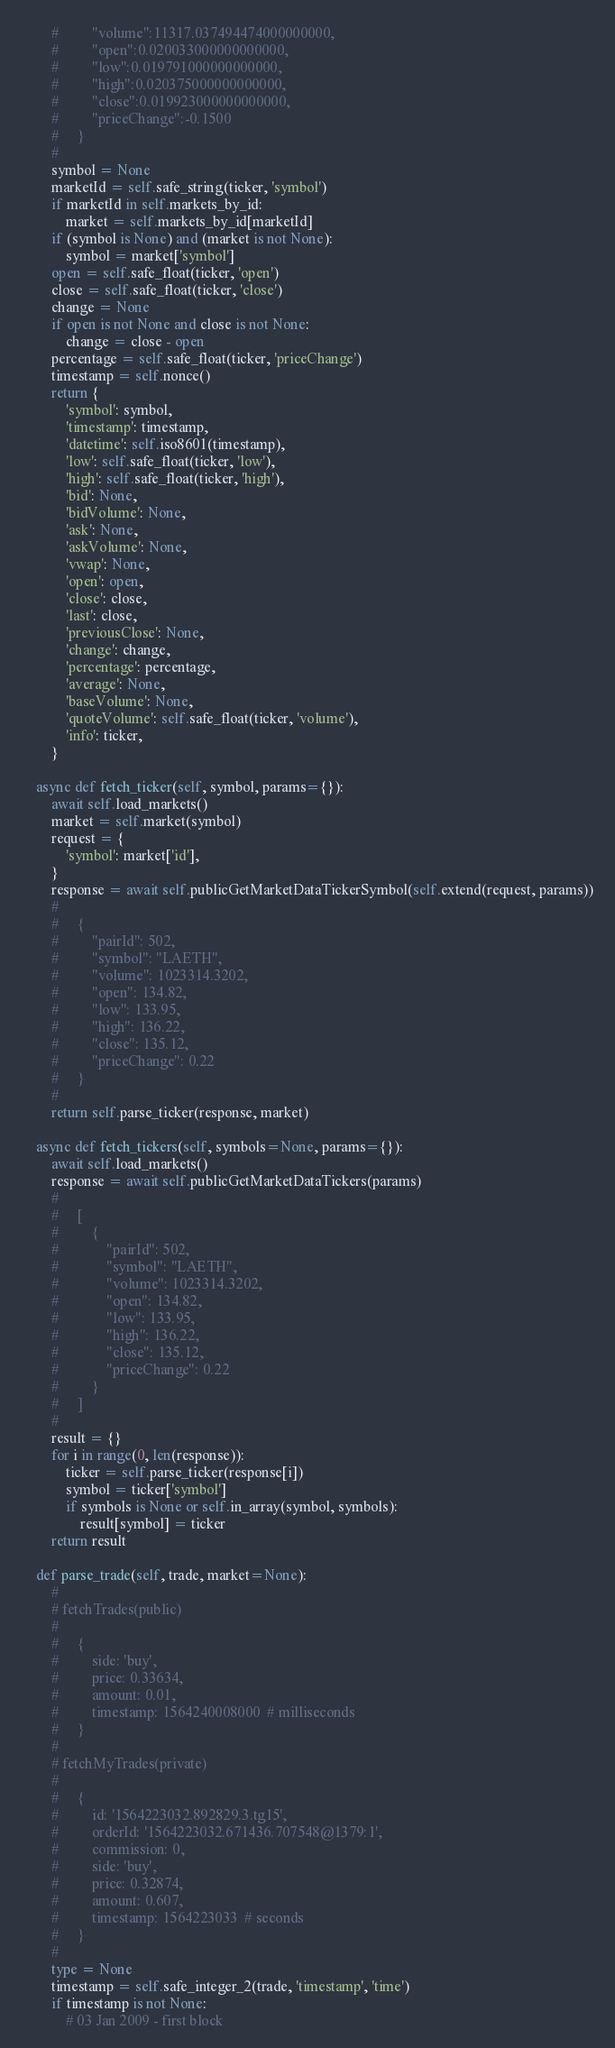<code> <loc_0><loc_0><loc_500><loc_500><_Python_>        #         "volume":11317.037494474000000000,
        #         "open":0.020033000000000000,
        #         "low":0.019791000000000000,
        #         "high":0.020375000000000000,
        #         "close":0.019923000000000000,
        #         "priceChange":-0.1500
        #     }
        #
        symbol = None
        marketId = self.safe_string(ticker, 'symbol')
        if marketId in self.markets_by_id:
            market = self.markets_by_id[marketId]
        if (symbol is None) and (market is not None):
            symbol = market['symbol']
        open = self.safe_float(ticker, 'open')
        close = self.safe_float(ticker, 'close')
        change = None
        if open is not None and close is not None:
            change = close - open
        percentage = self.safe_float(ticker, 'priceChange')
        timestamp = self.nonce()
        return {
            'symbol': symbol,
            'timestamp': timestamp,
            'datetime': self.iso8601(timestamp),
            'low': self.safe_float(ticker, 'low'),
            'high': self.safe_float(ticker, 'high'),
            'bid': None,
            'bidVolume': None,
            'ask': None,
            'askVolume': None,
            'vwap': None,
            'open': open,
            'close': close,
            'last': close,
            'previousClose': None,
            'change': change,
            'percentage': percentage,
            'average': None,
            'baseVolume': None,
            'quoteVolume': self.safe_float(ticker, 'volume'),
            'info': ticker,
        }

    async def fetch_ticker(self, symbol, params={}):
        await self.load_markets()
        market = self.market(symbol)
        request = {
            'symbol': market['id'],
        }
        response = await self.publicGetMarketDataTickerSymbol(self.extend(request, params))
        #
        #     {
        #         "pairId": 502,
        #         "symbol": "LAETH",
        #         "volume": 1023314.3202,
        #         "open": 134.82,
        #         "low": 133.95,
        #         "high": 136.22,
        #         "close": 135.12,
        #         "priceChange": 0.22
        #     }
        #
        return self.parse_ticker(response, market)

    async def fetch_tickers(self, symbols=None, params={}):
        await self.load_markets()
        response = await self.publicGetMarketDataTickers(params)
        #
        #     [
        #         {
        #             "pairId": 502,
        #             "symbol": "LAETH",
        #             "volume": 1023314.3202,
        #             "open": 134.82,
        #             "low": 133.95,
        #             "high": 136.22,
        #             "close": 135.12,
        #             "priceChange": 0.22
        #         }
        #     ]
        #
        result = {}
        for i in range(0, len(response)):
            ticker = self.parse_ticker(response[i])
            symbol = ticker['symbol']
            if symbols is None or self.in_array(symbol, symbols):
                result[symbol] = ticker
        return result

    def parse_trade(self, trade, market=None):
        #
        # fetchTrades(public)
        #
        #     {
        #         side: 'buy',
        #         price: 0.33634,
        #         amount: 0.01,
        #         timestamp: 1564240008000  # milliseconds
        #     }
        #
        # fetchMyTrades(private)
        #
        #     {
        #         id: '1564223032.892829.3.tg15',
        #         orderId: '1564223032.671436.707548@1379:1',
        #         commission: 0,
        #         side: 'buy',
        #         price: 0.32874,
        #         amount: 0.607,
        #         timestamp: 1564223033  # seconds
        #     }
        #
        type = None
        timestamp = self.safe_integer_2(trade, 'timestamp', 'time')
        if timestamp is not None:
            # 03 Jan 2009 - first block</code> 